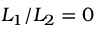<formula> <loc_0><loc_0><loc_500><loc_500>L _ { 1 } / L _ { 2 } = 0</formula> 